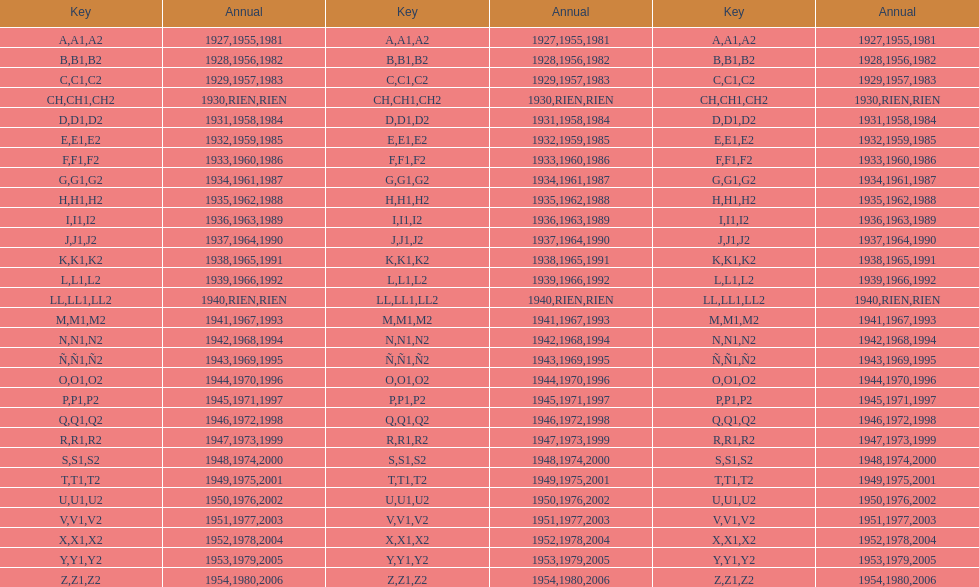What was the only year to use the code ch? 1930. 